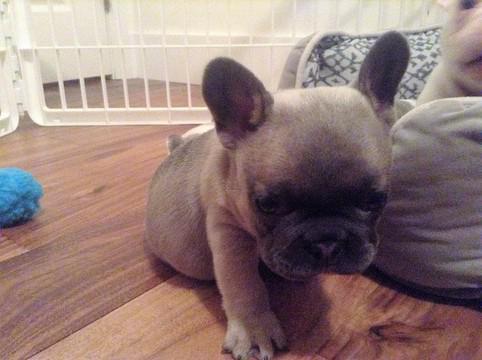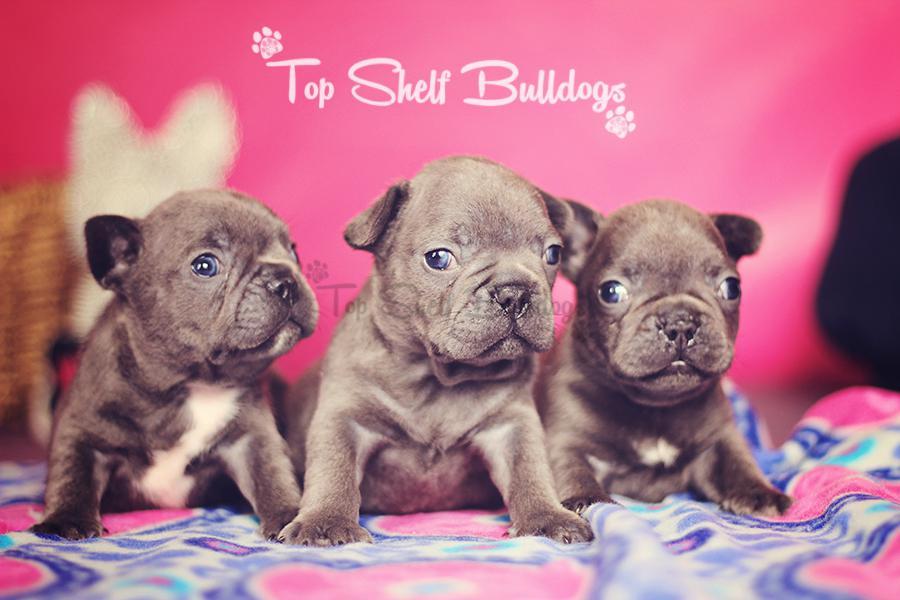The first image is the image on the left, the second image is the image on the right. Evaluate the accuracy of this statement regarding the images: "There is only one puppy in the picture on the left.". Is it true? Answer yes or no. Yes. The first image is the image on the left, the second image is the image on the right. Assess this claim about the two images: "An image shows a row of at least three puppies of the same overall color.". Correct or not? Answer yes or no. Yes. 